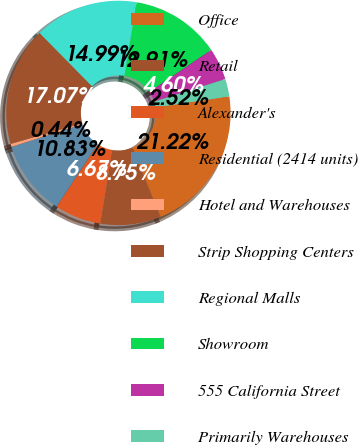Convert chart to OTSL. <chart><loc_0><loc_0><loc_500><loc_500><pie_chart><fcel>Office<fcel>Retail<fcel>Alexander's<fcel>Residential (2414 units)<fcel>Hotel and Warehouses<fcel>Strip Shopping Centers<fcel>Regional Malls<fcel>Showroom<fcel>555 California Street<fcel>Primarily Warehouses<nl><fcel>21.22%<fcel>8.75%<fcel>6.67%<fcel>10.83%<fcel>0.44%<fcel>17.07%<fcel>14.99%<fcel>12.91%<fcel>4.6%<fcel>2.52%<nl></chart> 